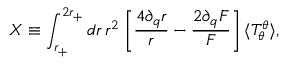Convert formula to latex. <formula><loc_0><loc_0><loc_500><loc_500>X \equiv \int _ { r _ { + } } ^ { 2 r _ { + } } d r \, r ^ { 2 } \, \left [ \frac { 4 \partial _ { q } r } { r } - \frac { 2 \partial _ { q } F } { F } \right ] \, \langle T _ { \theta } ^ { \theta } \rangle ,</formula> 